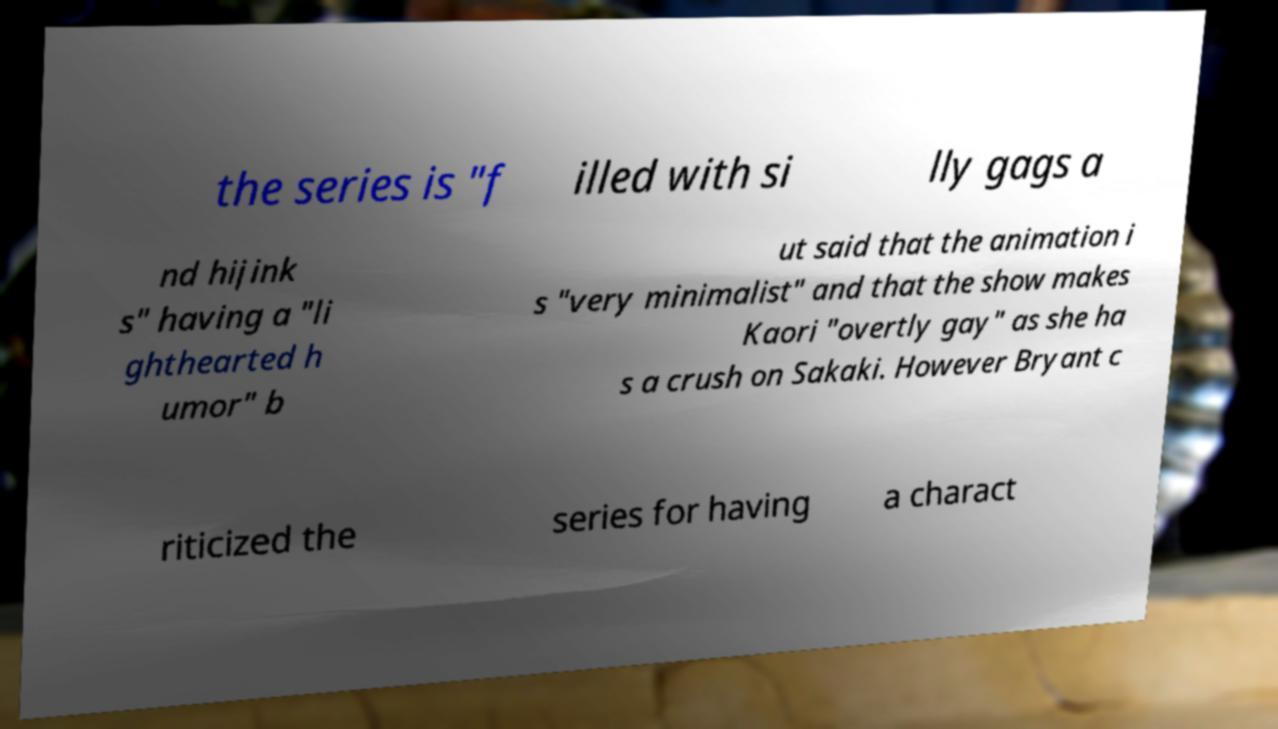Can you accurately transcribe the text from the provided image for me? the series is "f illed with si lly gags a nd hijink s" having a "li ghthearted h umor" b ut said that the animation i s "very minimalist" and that the show makes Kaori "overtly gay" as she ha s a crush on Sakaki. However Bryant c riticized the series for having a charact 